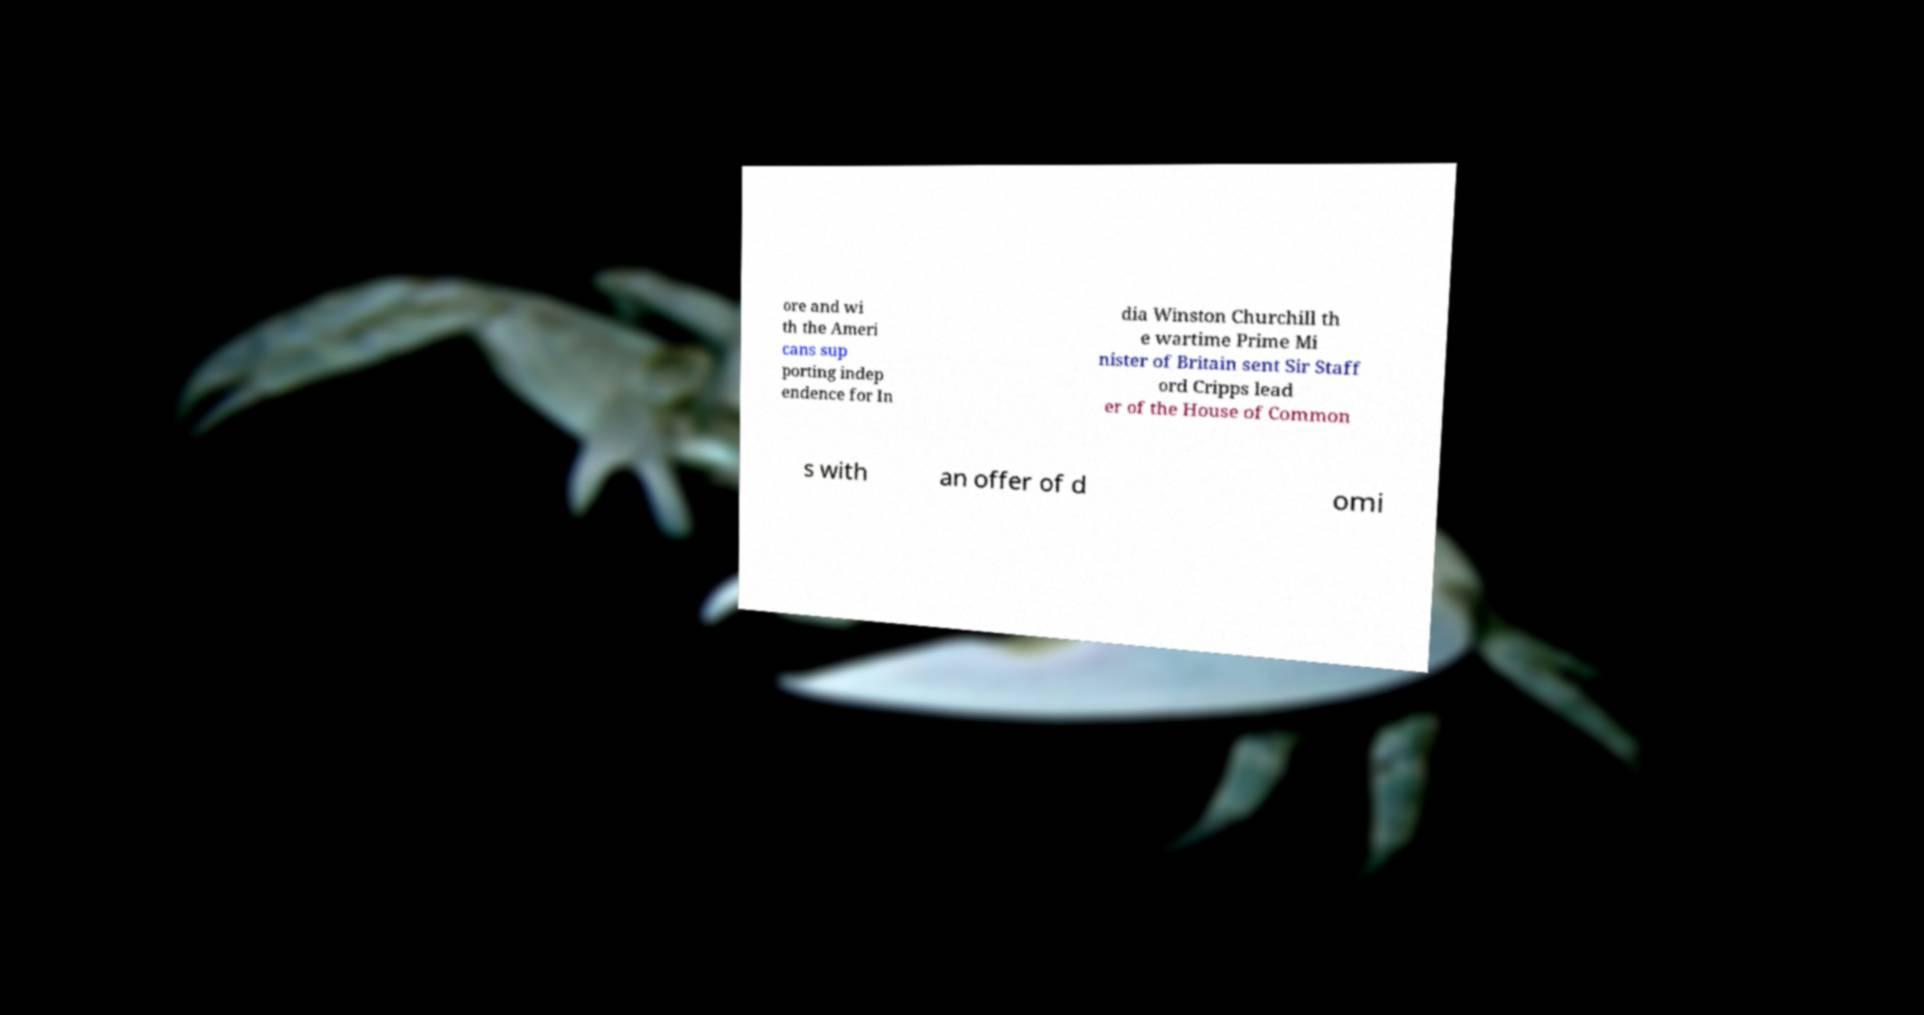Can you read and provide the text displayed in the image?This photo seems to have some interesting text. Can you extract and type it out for me? ore and wi th the Ameri cans sup porting indep endence for In dia Winston Churchill th e wartime Prime Mi nister of Britain sent Sir Staff ord Cripps lead er of the House of Common s with an offer of d omi 